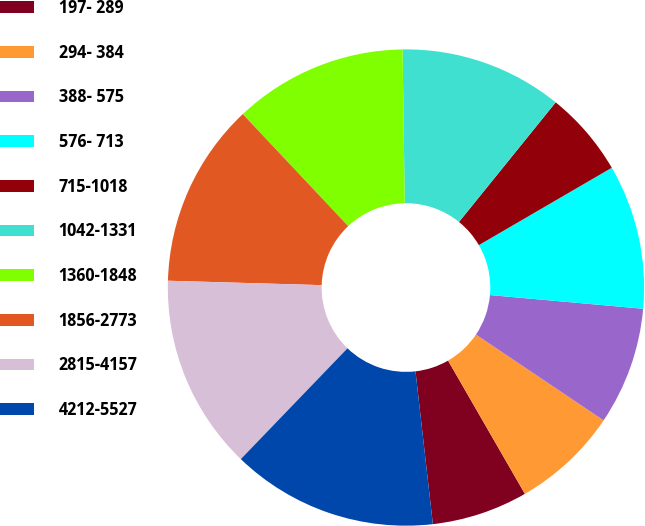<chart> <loc_0><loc_0><loc_500><loc_500><pie_chart><fcel>197- 289<fcel>294- 384<fcel>388- 575<fcel>576- 713<fcel>715-1018<fcel>1042-1331<fcel>1360-1848<fcel>1856-2773<fcel>2815-4157<fcel>4212-5527<nl><fcel>6.52%<fcel>7.26%<fcel>8.0%<fcel>9.81%<fcel>5.79%<fcel>11.05%<fcel>11.79%<fcel>12.53%<fcel>13.26%<fcel>14.0%<nl></chart> 